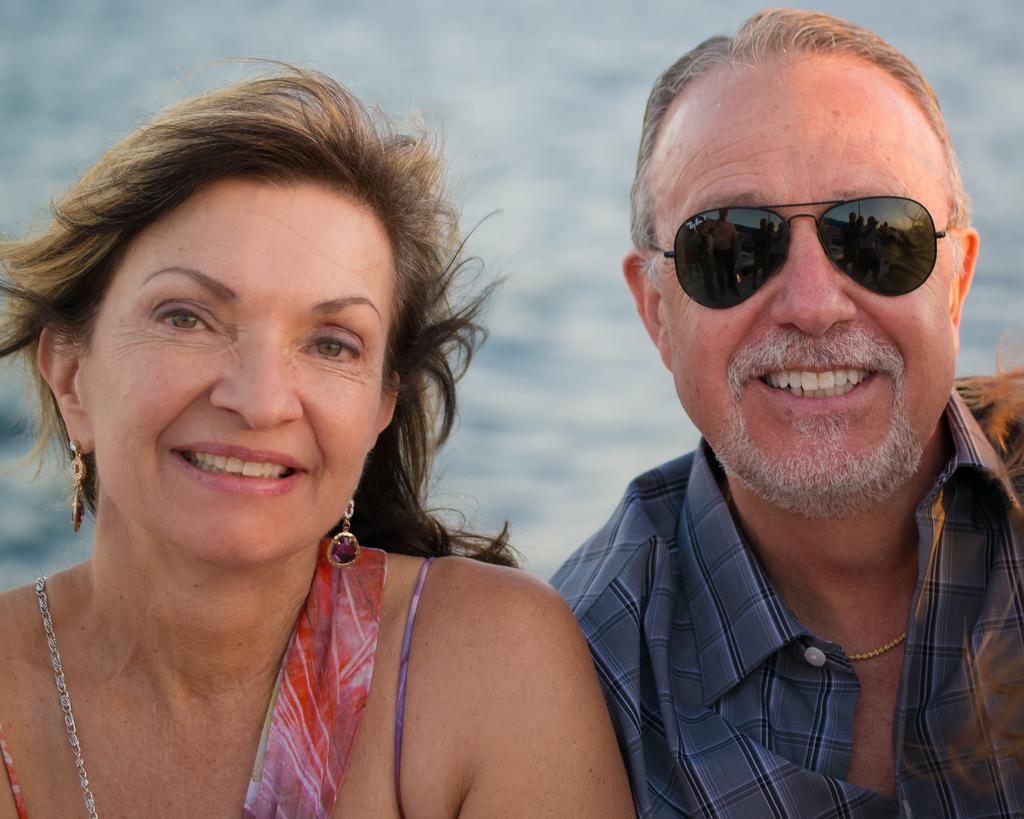How would you summarize this image in a sentence or two? In this image I see a woman and a man who are smiling and I see that this man is wearing black color shades and I see that it is blurred in the background and I see that this man is wearing a shirt. 